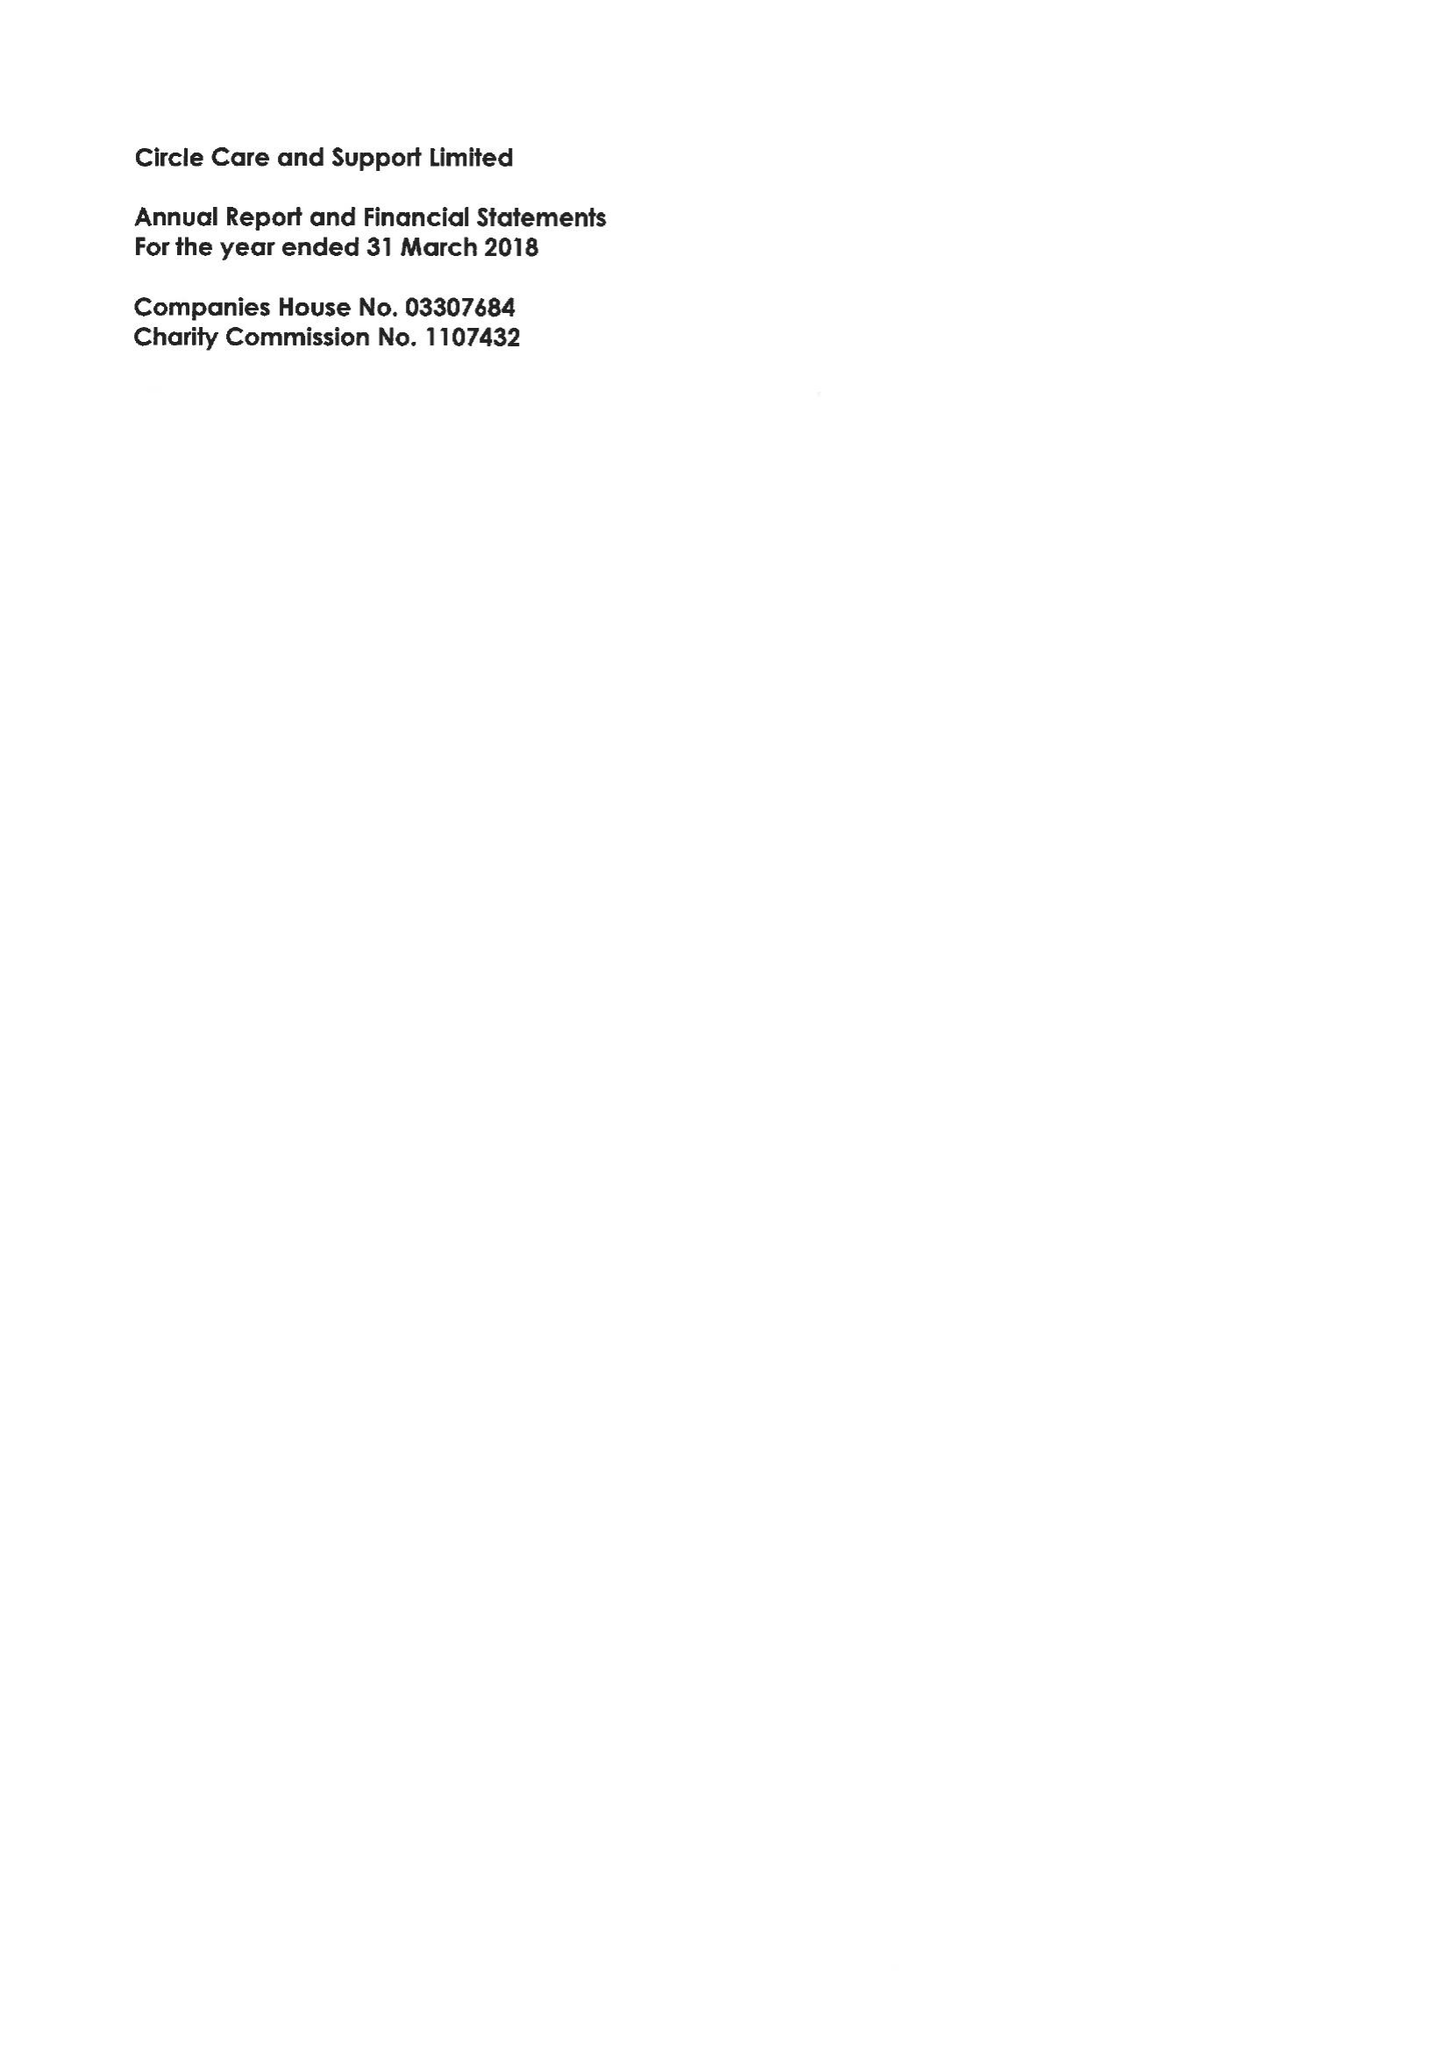What is the value for the spending_annually_in_british_pounds?
Answer the question using a single word or phrase. 13391000.00 